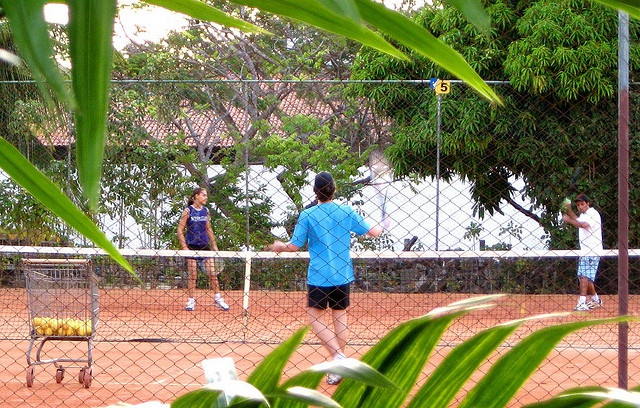Describe the objects in this image and their specific colors. I can see people in darkgreen, lightblue, black, and white tones, people in darkgreen, brown, navy, and salmon tones, people in darkgreen, white, brown, and darkgray tones, tennis racket in darkgreen, lightgray, darkgray, and gray tones, and tennis racket in darkgreen, gray, darkgray, and tan tones in this image. 